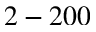<formula> <loc_0><loc_0><loc_500><loc_500>2 - 2 0 0</formula> 